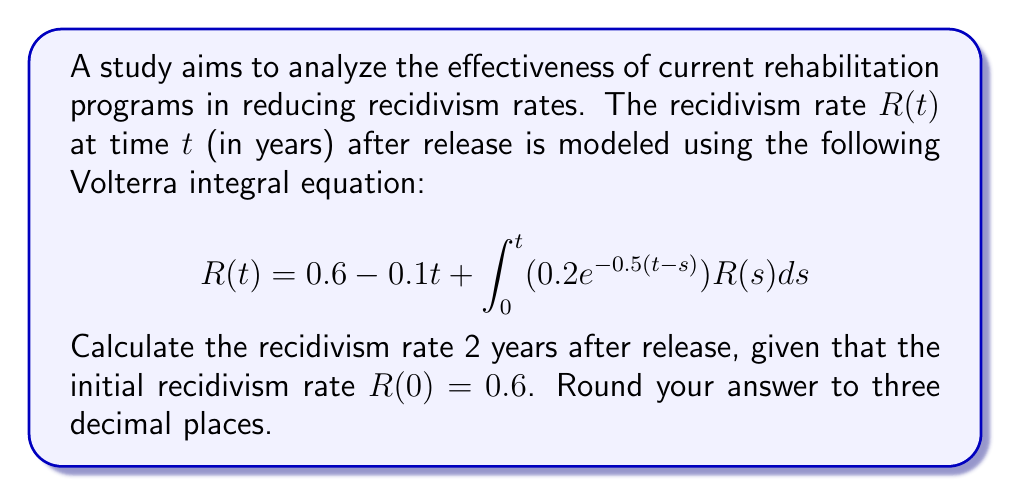Provide a solution to this math problem. To solve this Volterra integral equation, we'll use numerical methods, specifically the trapezoidal rule for integration and an iterative approach.

Step 1: Set up a grid of points. Let's use a step size of $h = 0.1$ years.
$t_i = 0, 0.1, 0.2, ..., 2.0$

Step 2: Initialize the solution vector $R_i$ with the known initial value:
$R_0 = 0.6$

Step 3: Use the trapezoidal rule to approximate the integral at each step:

$$R_i = 0.6 - 0.1t_i + h\left(\frac{1}{2}f(t_i,R_i) + \sum_{j=0}^{i-1}f(t_j,R_j)\right)$$

where $f(t,R) = 0.2e^{-0.5(t-s)}R$

Step 4: Implement the iterative process:

For $i = 1, 2, ..., 20$:
  1. Guess $R_i = R_{i-1}$
  2. Calculate new $R_i$ using the formula in Step 3
  3. Repeat until convergence

Step 5: After completing the iterations, $R_{20}$ gives the recidivism rate at $t = 2$ years.

Implementing this process (which would typically be done using a computer), we find:

$R_{20} \approx 0.447$
Answer: 0.447 